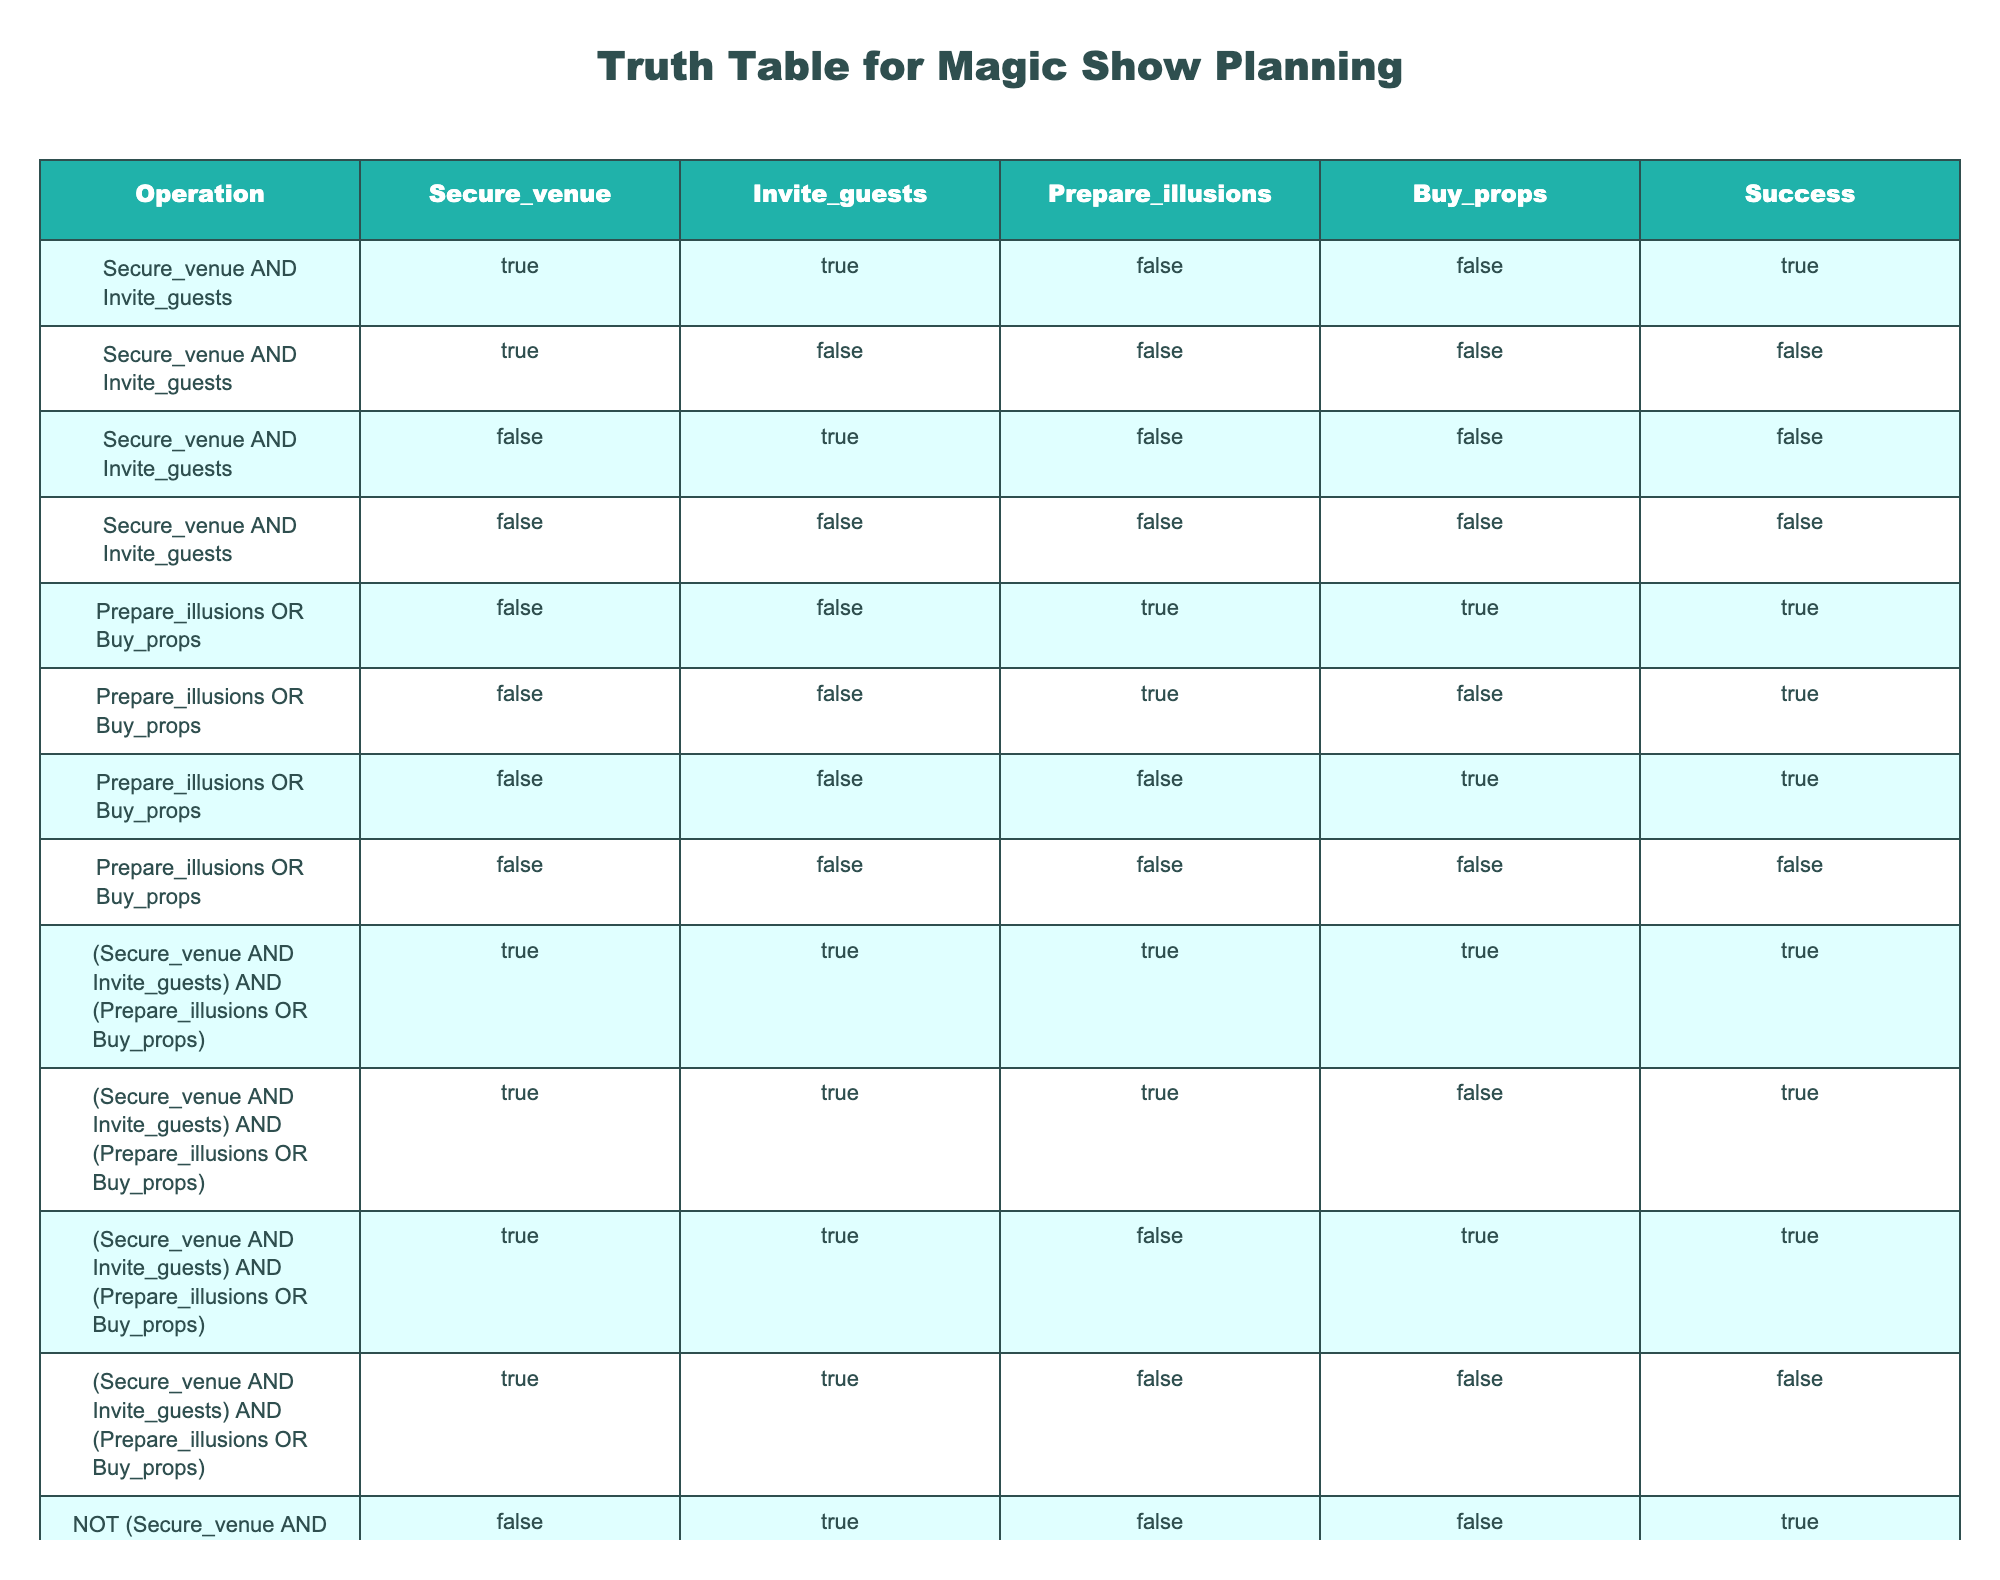What is the result when both the venue is secured and guests are invited? If both "Secure_venue" and "Invite_guests" are TRUE, we see in row 1 that the success is also TRUE. Hence, when both conditions are met, it ensures success for the show.
Answer: TRUE What happens if we only prepare illusions and do not buy any props? According to rows 5, 6, and 8, if "Prepare_illusions" is TRUE while "Buy_props" is FALSE, the success is still TRUE in those scenarios. Therefore, it shows that preparing illusions alone can lead to success.
Answer: TRUE Are there any scenarios where the venue can be secured and guests invited without success? Referring to rows 4 and 7, when both "Secure_venue" and "Invite_guests" are TRUE but "Prepare_illusions" and "Buy_props" do not contribute positively, the success could be FALSE. Thus, it is confirmed that it is possible.
Answer: TRUE If the venue is not secured and guests are invited, is it a success? Looking at rows 3 and 4, when "Secure_venue" is FALSE, whether or not guests are invited, the success result is FALSE. Thus, it demonstrates that without securing the venue, success is unattainable.
Answer: FALSE What is the combined success status when illusions are prepared or props are bought? Checking through rows labeled under the operation "Prepare_illusions OR Buy_props," we see that there are three instances where this results in success, indicating that at least one of the activities leads to success. Hence, when either activity occurs, the outcome is generally successful.
Answer: TRUE In how many scenarios is it required to have both a secured venue and invited guests for the show to be successful? From the rows concerning the operation "Secure_venue AND Invite_guests," we can see that there are two cases where both those conditions resulted in success (rows 1 and 3). This means it confirms the necessity of these conditions for overall success in planning the show.
Answer: 2 If neither the venue is secured nor guests invited, is any success possible? Rows 4 and 8 indicate both instances show success is FALSE. Thus, it is clear that with both conditions FALSE, success cannot happen in any circumstance.
Answer: FALSE How many total scenarios allow for success given any combination of securing a venue, inviting guests, preparing illusions, and buying props? By evaluating all successful rows (1, 5, 6, 8, 9, 10), we find there are a total of 6 combinations that reflect a successful outcome, demonstrating various ways to achieve success.
Answer: 6 